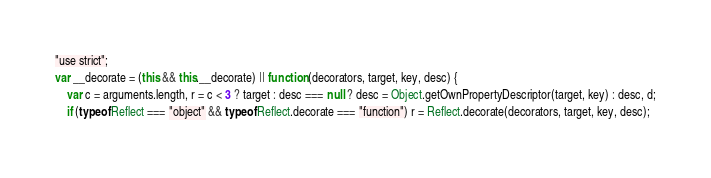Convert code to text. <code><loc_0><loc_0><loc_500><loc_500><_JavaScript_>"use strict";
var __decorate = (this && this.__decorate) || function (decorators, target, key, desc) {
    var c = arguments.length, r = c < 3 ? target : desc === null ? desc = Object.getOwnPropertyDescriptor(target, key) : desc, d;
    if (typeof Reflect === "object" && typeof Reflect.decorate === "function") r = Reflect.decorate(decorators, target, key, desc);</code> 